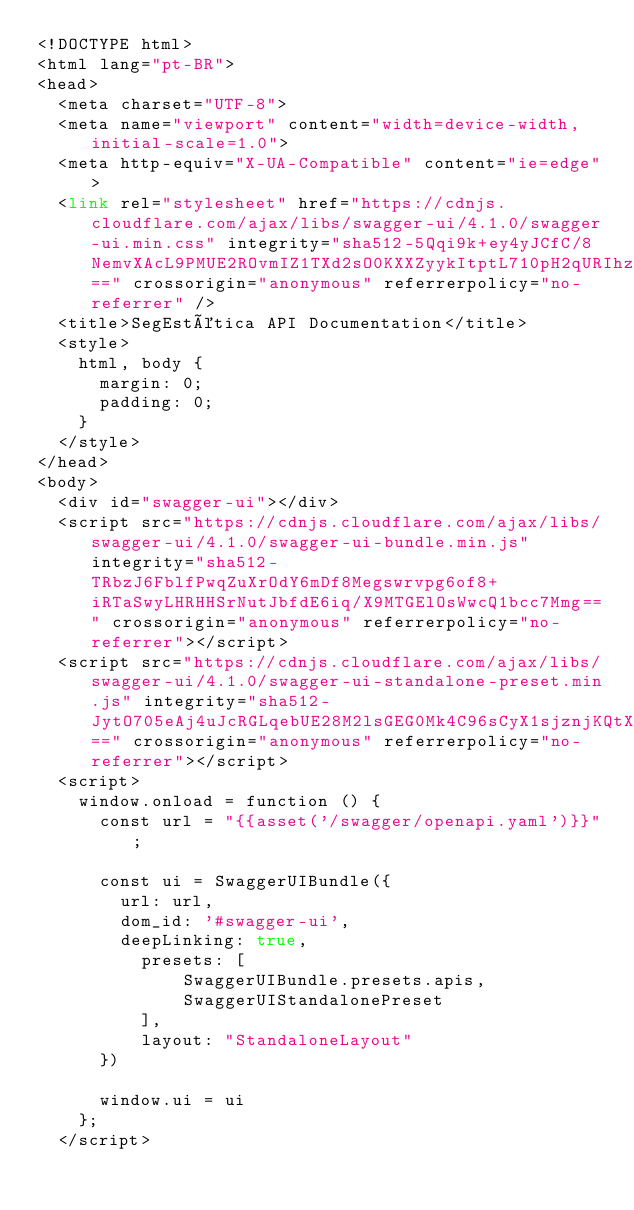Convert code to text. <code><loc_0><loc_0><loc_500><loc_500><_PHP_><!DOCTYPE html>
<html lang="pt-BR">
<head>
  <meta charset="UTF-8">
  <meta name="viewport" content="width=device-width, initial-scale=1.0">
  <meta http-equiv="X-UA-Compatible" content="ie=edge">
  <link rel="stylesheet" href="https://cdnjs.cloudflare.com/ajax/libs/swagger-ui/4.1.0/swagger-ui.min.css" integrity="sha512-5Qqi9k+ey4yJCfC/8NemvXAcL9PMUE2ROvmIZ1TXd2sO0KXXZyykItptL710pH2qURIhzeqeidjZIDVtt3sHDA==" crossorigin="anonymous" referrerpolicy="no-referrer" />
  <title>SegEstética API Documentation</title>
  <style>
    html, body {
      margin: 0;
      padding: 0;
    }
  </style>
</head>
<body>
  <div id="swagger-ui"></div>
  <script src="https://cdnjs.cloudflare.com/ajax/libs/swagger-ui/4.1.0/swagger-ui-bundle.min.js" integrity="sha512-TRbzJ6FblfPwqZuXrOdY6mDf8Megswrvpg6of8+iRTaSwyLHRHHSrNutJbfdE6iq/X9MTGElOsWwcQ1bcc7Mmg==" crossorigin="anonymous" referrerpolicy="no-referrer"></script>
  <script src="https://cdnjs.cloudflare.com/ajax/libs/swagger-ui/4.1.0/swagger-ui-standalone-preset.min.js" integrity="sha512-JytO705eAj4uJcRGLqebUE28M2lsGEG0Mk4C96sCyX1sjznjKQtX0R6NDkKacqG6dAXu5KfeGmcZIwcDtPi2TQ==" crossorigin="anonymous" referrerpolicy="no-referrer"></script>
  <script>
    window.onload = function () {
      const url = "{{asset('/swagger/openapi.yaml')}}";
      
      const ui = SwaggerUIBundle({
        url: url,
        dom_id: '#swagger-ui',
        deepLinking: true,
          presets: [
              SwaggerUIBundle.presets.apis,
              SwaggerUIStandalonePreset
          ],
          layout: "StandaloneLayout"
      })

      window.ui = ui
    };
  </script></code> 